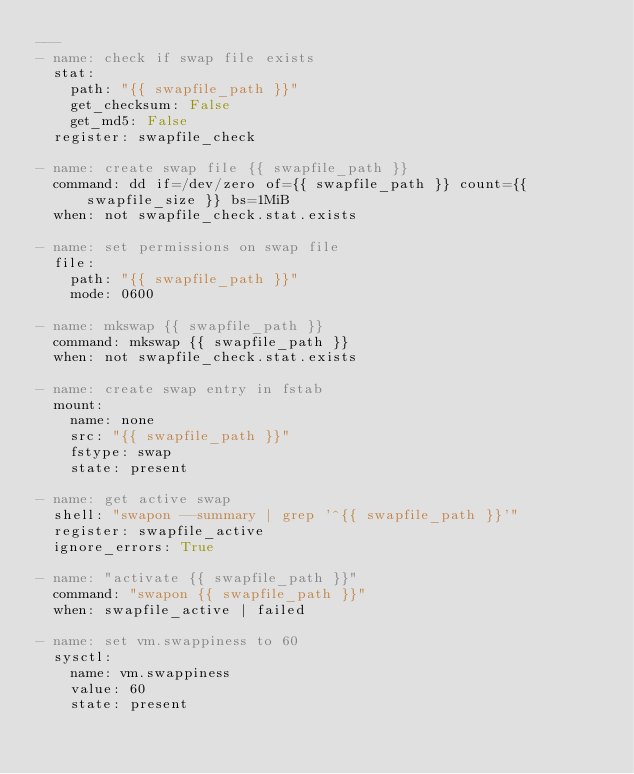<code> <loc_0><loc_0><loc_500><loc_500><_YAML_>---
- name: check if swap file exists
  stat:
    path: "{{ swapfile_path }}"
    get_checksum: False
    get_md5: False
  register: swapfile_check

- name: create swap file {{ swapfile_path }}
  command: dd if=/dev/zero of={{ swapfile_path }} count={{ swapfile_size }} bs=1MiB
  when: not swapfile_check.stat.exists

- name: set permissions on swap file
  file:
    path: "{{ swapfile_path }}"
    mode: 0600

- name: mkswap {{ swapfile_path }}
  command: mkswap {{ swapfile_path }}
  when: not swapfile_check.stat.exists

- name: create swap entry in fstab
  mount:
    name: none
    src: "{{ swapfile_path }}"
    fstype: swap
    state: present

- name: get active swap
  shell: "swapon --summary | grep '^{{ swapfile_path }}'"
  register: swapfile_active
  ignore_errors: True

- name: "activate {{ swapfile_path }}"
  command: "swapon {{ swapfile_path }}"
  when: swapfile_active | failed

- name: set vm.swappiness to 60
  sysctl:
    name: vm.swappiness
    value: 60
    state: present
</code> 